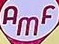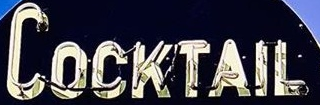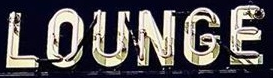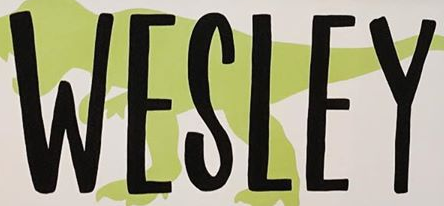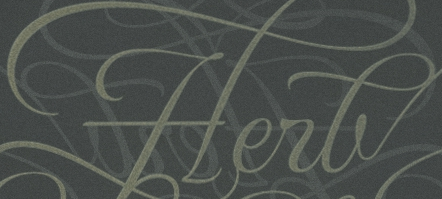Read the text content from these images in order, separated by a semicolon. AMF; COCKTAIL; LOUNGE; WESLEY; Herb 